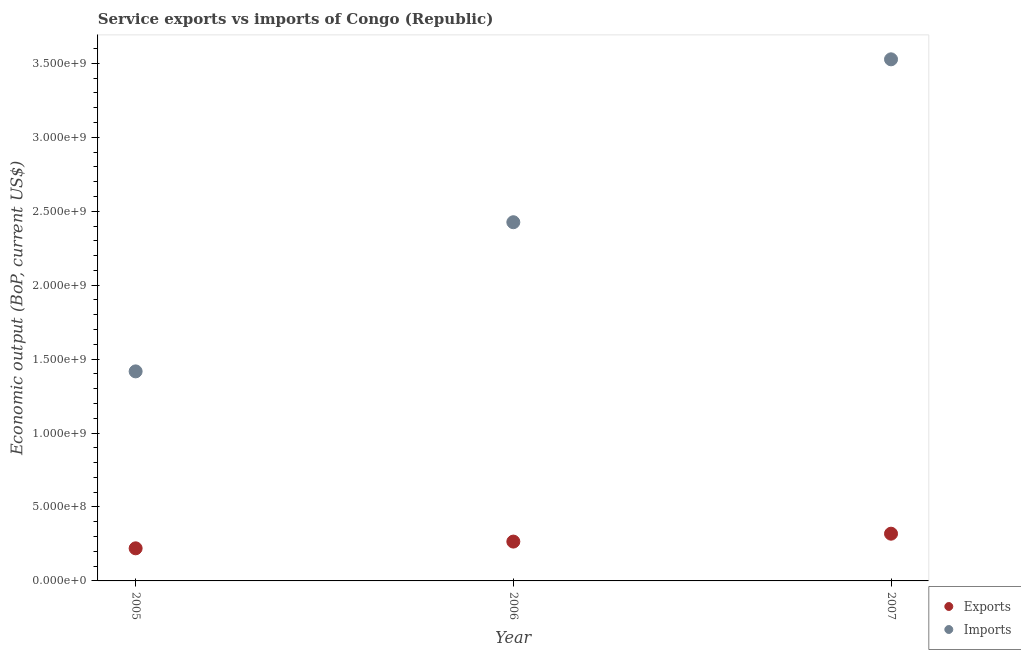What is the amount of service imports in 2006?
Your answer should be compact. 2.43e+09. Across all years, what is the maximum amount of service exports?
Ensure brevity in your answer.  3.19e+08. Across all years, what is the minimum amount of service imports?
Your answer should be compact. 1.42e+09. In which year was the amount of service imports maximum?
Keep it short and to the point. 2007. In which year was the amount of service exports minimum?
Provide a short and direct response. 2005. What is the total amount of service exports in the graph?
Your response must be concise. 8.06e+08. What is the difference between the amount of service imports in 2006 and that in 2007?
Make the answer very short. -1.10e+09. What is the difference between the amount of service imports in 2007 and the amount of service exports in 2006?
Your response must be concise. 3.26e+09. What is the average amount of service exports per year?
Your answer should be compact. 2.69e+08. In the year 2006, what is the difference between the amount of service imports and amount of service exports?
Ensure brevity in your answer.  2.16e+09. What is the ratio of the amount of service exports in 2005 to that in 2007?
Provide a short and direct response. 0.69. Is the difference between the amount of service exports in 2006 and 2007 greater than the difference between the amount of service imports in 2006 and 2007?
Your response must be concise. Yes. What is the difference between the highest and the second highest amount of service exports?
Keep it short and to the point. 5.34e+07. What is the difference between the highest and the lowest amount of service exports?
Your response must be concise. 9.90e+07. In how many years, is the amount of service exports greater than the average amount of service exports taken over all years?
Your answer should be compact. 1. Does the amount of service exports monotonically increase over the years?
Keep it short and to the point. Yes. Are the values on the major ticks of Y-axis written in scientific E-notation?
Offer a terse response. Yes. Does the graph contain grids?
Offer a terse response. No. How are the legend labels stacked?
Your answer should be compact. Vertical. What is the title of the graph?
Your answer should be very brief. Service exports vs imports of Congo (Republic). What is the label or title of the X-axis?
Your answer should be very brief. Year. What is the label or title of the Y-axis?
Your answer should be compact. Economic output (BoP, current US$). What is the Economic output (BoP, current US$) of Exports in 2005?
Ensure brevity in your answer.  2.20e+08. What is the Economic output (BoP, current US$) in Imports in 2005?
Your response must be concise. 1.42e+09. What is the Economic output (BoP, current US$) of Exports in 2006?
Offer a very short reply. 2.66e+08. What is the Economic output (BoP, current US$) of Imports in 2006?
Ensure brevity in your answer.  2.43e+09. What is the Economic output (BoP, current US$) in Exports in 2007?
Ensure brevity in your answer.  3.19e+08. What is the Economic output (BoP, current US$) of Imports in 2007?
Ensure brevity in your answer.  3.53e+09. Across all years, what is the maximum Economic output (BoP, current US$) in Exports?
Provide a succinct answer. 3.19e+08. Across all years, what is the maximum Economic output (BoP, current US$) of Imports?
Ensure brevity in your answer.  3.53e+09. Across all years, what is the minimum Economic output (BoP, current US$) in Exports?
Provide a succinct answer. 2.20e+08. Across all years, what is the minimum Economic output (BoP, current US$) of Imports?
Provide a succinct answer. 1.42e+09. What is the total Economic output (BoP, current US$) in Exports in the graph?
Ensure brevity in your answer.  8.06e+08. What is the total Economic output (BoP, current US$) in Imports in the graph?
Keep it short and to the point. 7.37e+09. What is the difference between the Economic output (BoP, current US$) in Exports in 2005 and that in 2006?
Your response must be concise. -4.55e+07. What is the difference between the Economic output (BoP, current US$) of Imports in 2005 and that in 2006?
Your answer should be very brief. -1.01e+09. What is the difference between the Economic output (BoP, current US$) of Exports in 2005 and that in 2007?
Provide a short and direct response. -9.90e+07. What is the difference between the Economic output (BoP, current US$) of Imports in 2005 and that in 2007?
Provide a succinct answer. -2.11e+09. What is the difference between the Economic output (BoP, current US$) of Exports in 2006 and that in 2007?
Offer a very short reply. -5.34e+07. What is the difference between the Economic output (BoP, current US$) in Imports in 2006 and that in 2007?
Give a very brief answer. -1.10e+09. What is the difference between the Economic output (BoP, current US$) of Exports in 2005 and the Economic output (BoP, current US$) of Imports in 2006?
Your answer should be compact. -2.21e+09. What is the difference between the Economic output (BoP, current US$) in Exports in 2005 and the Economic output (BoP, current US$) in Imports in 2007?
Make the answer very short. -3.31e+09. What is the difference between the Economic output (BoP, current US$) in Exports in 2006 and the Economic output (BoP, current US$) in Imports in 2007?
Offer a terse response. -3.26e+09. What is the average Economic output (BoP, current US$) in Exports per year?
Your answer should be very brief. 2.69e+08. What is the average Economic output (BoP, current US$) in Imports per year?
Provide a succinct answer. 2.46e+09. In the year 2005, what is the difference between the Economic output (BoP, current US$) in Exports and Economic output (BoP, current US$) in Imports?
Ensure brevity in your answer.  -1.20e+09. In the year 2006, what is the difference between the Economic output (BoP, current US$) of Exports and Economic output (BoP, current US$) of Imports?
Keep it short and to the point. -2.16e+09. In the year 2007, what is the difference between the Economic output (BoP, current US$) of Exports and Economic output (BoP, current US$) of Imports?
Your answer should be compact. -3.21e+09. What is the ratio of the Economic output (BoP, current US$) in Exports in 2005 to that in 2006?
Provide a succinct answer. 0.83. What is the ratio of the Economic output (BoP, current US$) of Imports in 2005 to that in 2006?
Provide a short and direct response. 0.58. What is the ratio of the Economic output (BoP, current US$) in Exports in 2005 to that in 2007?
Your response must be concise. 0.69. What is the ratio of the Economic output (BoP, current US$) of Imports in 2005 to that in 2007?
Your response must be concise. 0.4. What is the ratio of the Economic output (BoP, current US$) in Exports in 2006 to that in 2007?
Offer a very short reply. 0.83. What is the ratio of the Economic output (BoP, current US$) of Imports in 2006 to that in 2007?
Your answer should be compact. 0.69. What is the difference between the highest and the second highest Economic output (BoP, current US$) in Exports?
Your response must be concise. 5.34e+07. What is the difference between the highest and the second highest Economic output (BoP, current US$) of Imports?
Make the answer very short. 1.10e+09. What is the difference between the highest and the lowest Economic output (BoP, current US$) in Exports?
Provide a succinct answer. 9.90e+07. What is the difference between the highest and the lowest Economic output (BoP, current US$) of Imports?
Provide a succinct answer. 2.11e+09. 